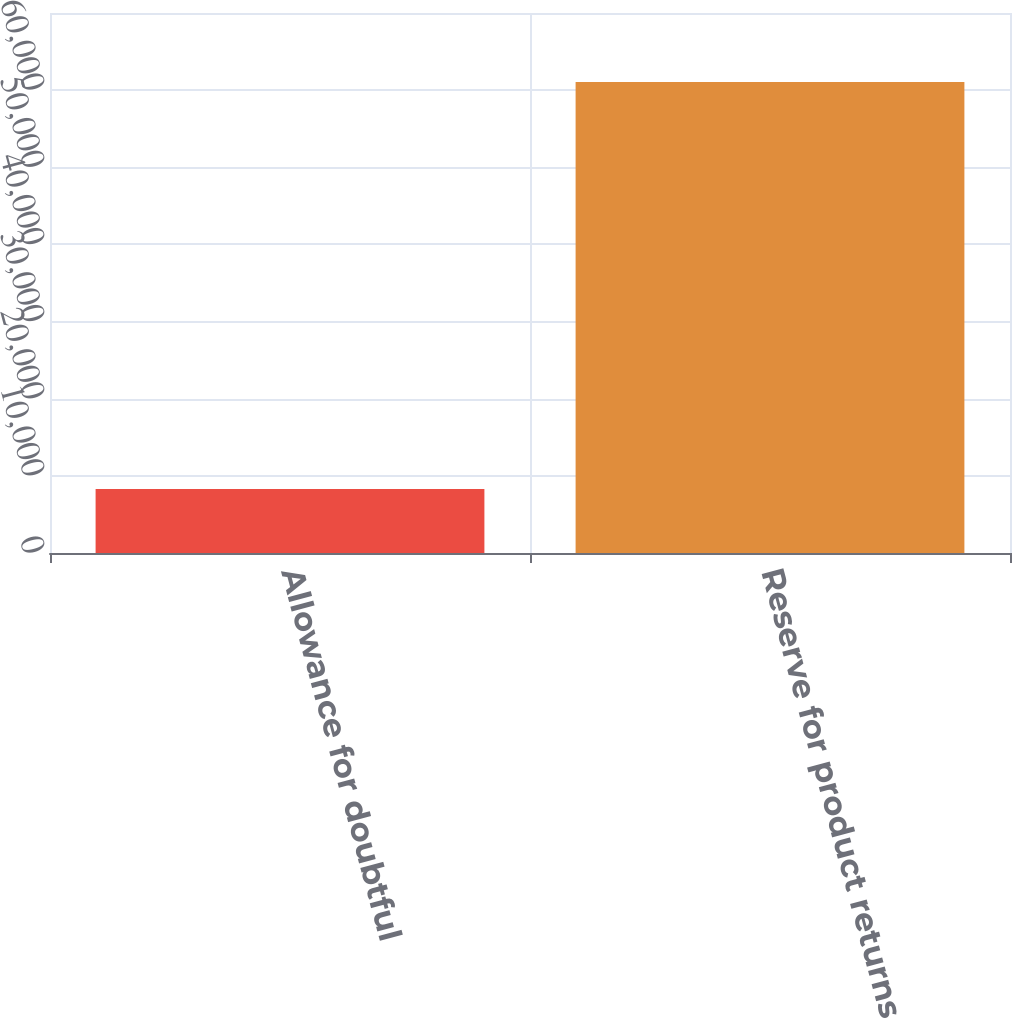<chart> <loc_0><loc_0><loc_500><loc_500><bar_chart><fcel>Allowance for doubtful<fcel>Reserve for product returns<nl><fcel>8286<fcel>61053<nl></chart> 